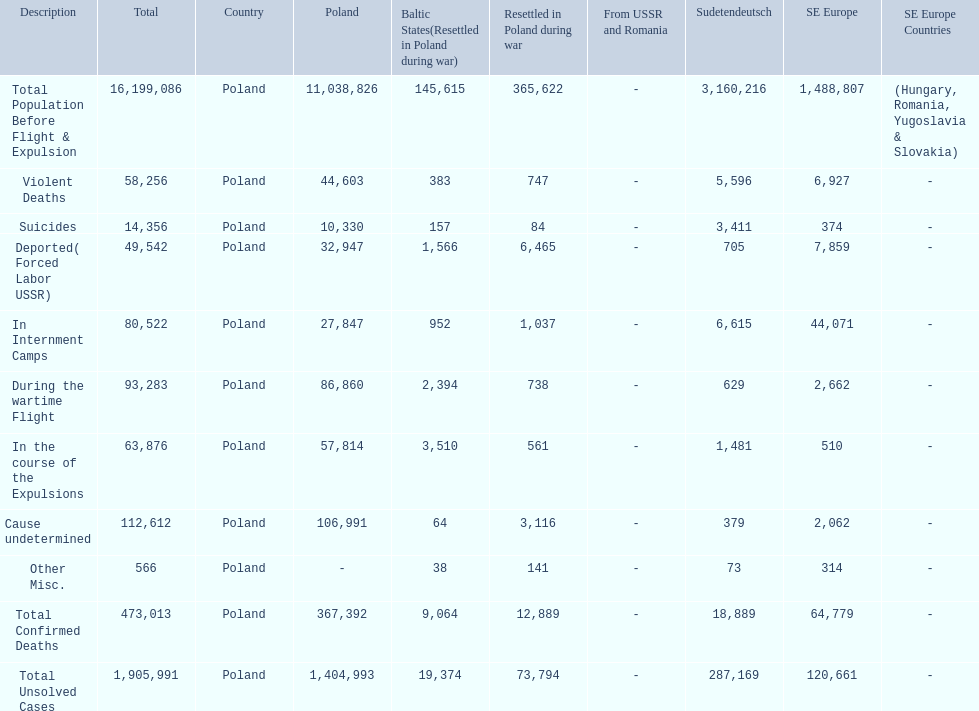How many deaths did the baltic states have in each category? 145,615, 383, 157, 1,566, 952, 2,394, 3,510, 64, 38, 9,064, 19,374. How many cause undetermined deaths did baltic states have? 64. How many other miscellaneous deaths did baltic states have? 38. Which is higher in deaths, cause undetermined or other miscellaneous? Cause undetermined. 